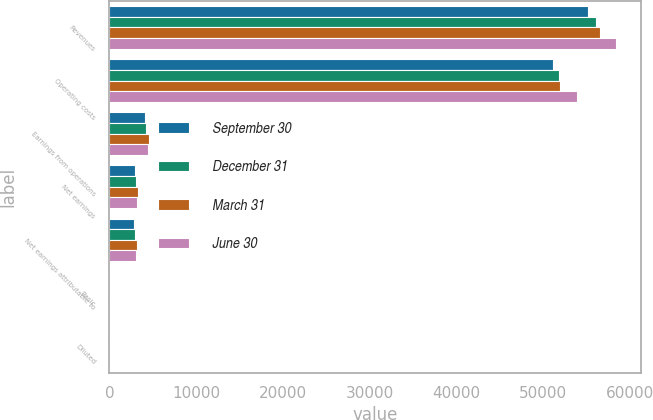<chart> <loc_0><loc_0><loc_500><loc_500><stacked_bar_chart><ecel><fcel>Revenues<fcel>Operating costs<fcel>Earnings from operations<fcel>Net earnings<fcel>Net earnings attributable to<fcel>Basic<fcel>Diluted<nl><fcel>September 30<fcel>55188<fcel>51135<fcel>4053<fcel>2924<fcel>2836<fcel>2.94<fcel>2.87<nl><fcel>December 31<fcel>56086<fcel>51882<fcel>4204<fcel>3010<fcel>2922<fcel>3.04<fcel>2.98<nl><fcel>March 31<fcel>56556<fcel>51966<fcel>4590<fcel>3284<fcel>3188<fcel>3.31<fcel>3.24<nl><fcel>June 30<fcel>58417<fcel>53920<fcel>4497<fcel>3164<fcel>3040<fcel>3.16<fcel>3.1<nl></chart> 